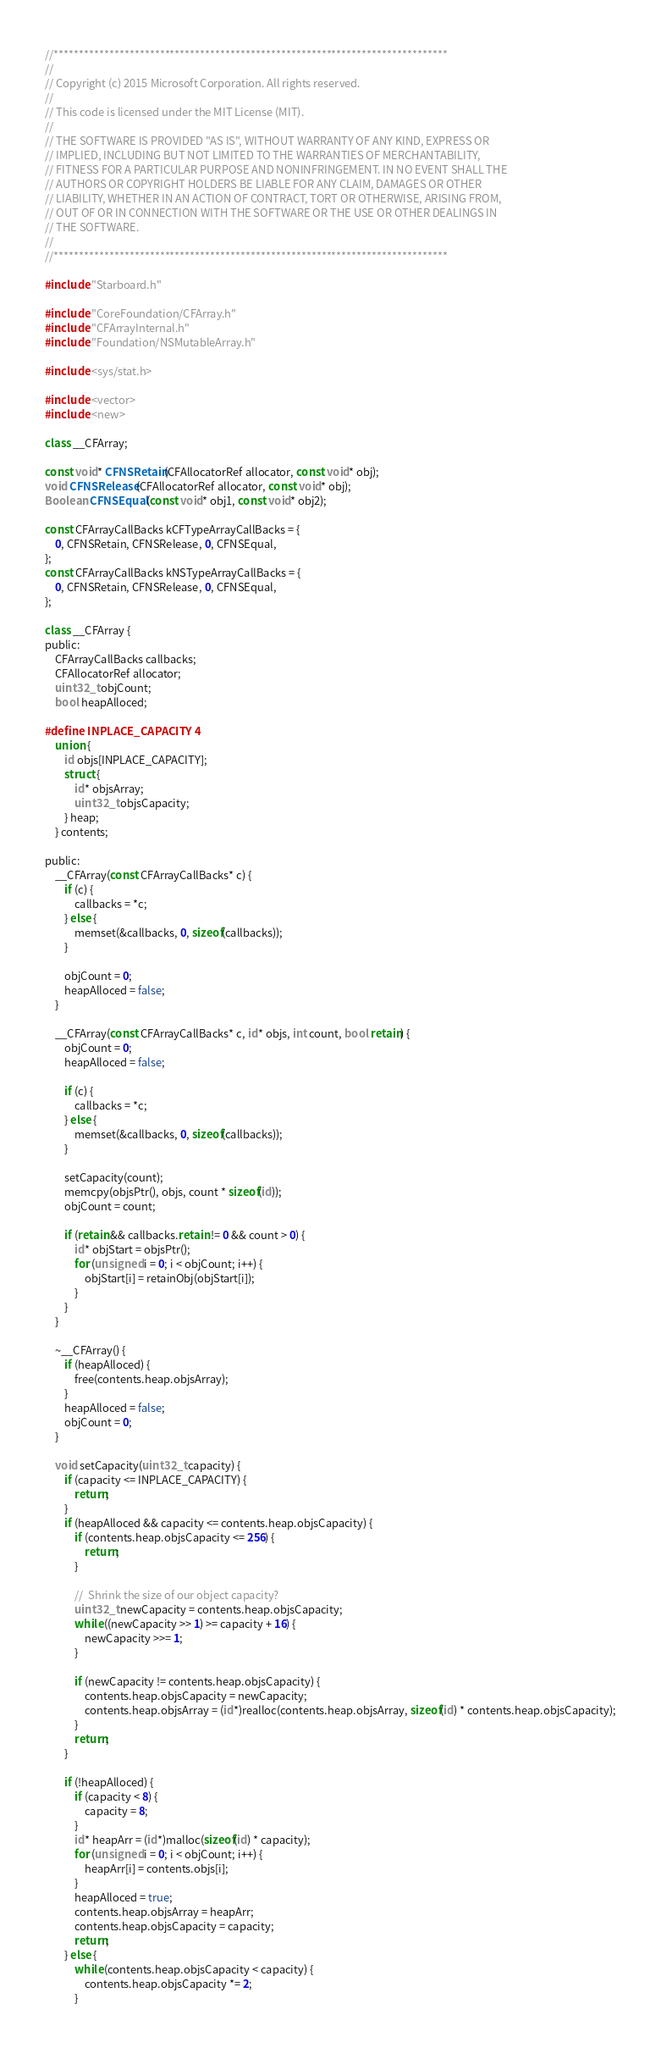Convert code to text. <code><loc_0><loc_0><loc_500><loc_500><_ObjectiveC_>//******************************************************************************
//
// Copyright (c) 2015 Microsoft Corporation. All rights reserved.
//
// This code is licensed under the MIT License (MIT).
//
// THE SOFTWARE IS PROVIDED "AS IS", WITHOUT WARRANTY OF ANY KIND, EXPRESS OR
// IMPLIED, INCLUDING BUT NOT LIMITED TO THE WARRANTIES OF MERCHANTABILITY,
// FITNESS FOR A PARTICULAR PURPOSE AND NONINFRINGEMENT. IN NO EVENT SHALL THE
// AUTHORS OR COPYRIGHT HOLDERS BE LIABLE FOR ANY CLAIM, DAMAGES OR OTHER
// LIABILITY, WHETHER IN AN ACTION OF CONTRACT, TORT OR OTHERWISE, ARISING FROM,
// OUT OF OR IN CONNECTION WITH THE SOFTWARE OR THE USE OR OTHER DEALINGS IN
// THE SOFTWARE.
//
//******************************************************************************

#include "Starboard.h"

#include "CoreFoundation/CFArray.h"
#include "CFArrayInternal.h"
#include "Foundation/NSMutableArray.h"

#include <sys/stat.h>

#include <vector>
#include <new>

class __CFArray;

const void* CFNSRetain(CFAllocatorRef allocator, const void* obj);
void CFNSRelease(CFAllocatorRef allocator, const void* obj);
Boolean CFNSEqual(const void* obj1, const void* obj2);

const CFArrayCallBacks kCFTypeArrayCallBacks = {
    0, CFNSRetain, CFNSRelease, 0, CFNSEqual,
};
const CFArrayCallBacks kNSTypeArrayCallBacks = {
    0, CFNSRetain, CFNSRelease, 0, CFNSEqual,
};

class __CFArray {
public:
    CFArrayCallBacks callbacks;
    CFAllocatorRef allocator;
    uint32_t objCount;
    bool heapAlloced;

#define INPLACE_CAPACITY 4
    union {
        id objs[INPLACE_CAPACITY];
        struct {
            id* objsArray;
            uint32_t objsCapacity;
        } heap;
    } contents;

public:
    __CFArray(const CFArrayCallBacks* c) {
        if (c) {
            callbacks = *c;
        } else {
            memset(&callbacks, 0, sizeof(callbacks));
        }

        objCount = 0;
        heapAlloced = false;
    }

    __CFArray(const CFArrayCallBacks* c, id* objs, int count, bool retain) {
        objCount = 0;
        heapAlloced = false;

        if (c) {
            callbacks = *c;
        } else {
            memset(&callbacks, 0, sizeof(callbacks));
        }

        setCapacity(count);
        memcpy(objsPtr(), objs, count * sizeof(id));
        objCount = count;

        if (retain && callbacks.retain != 0 && count > 0) {
            id* objStart = objsPtr();
            for (unsigned i = 0; i < objCount; i++) {
                objStart[i] = retainObj(objStart[i]);
            }
        }
    }

    ~__CFArray() {
        if (heapAlloced) {
            free(contents.heap.objsArray);
        }
        heapAlloced = false;
        objCount = 0;
    }

    void setCapacity(uint32_t capacity) {
        if (capacity <= INPLACE_CAPACITY) {
            return;
        }
        if (heapAlloced && capacity <= contents.heap.objsCapacity) {
            if (contents.heap.objsCapacity <= 256) {
                return;
            }

            //  Shrink the size of our object capacity?
            uint32_t newCapacity = contents.heap.objsCapacity;
            while ((newCapacity >> 1) >= capacity + 16) {
                newCapacity >>= 1;
            }

            if (newCapacity != contents.heap.objsCapacity) {
                contents.heap.objsCapacity = newCapacity;
                contents.heap.objsArray = (id*)realloc(contents.heap.objsArray, sizeof(id) * contents.heap.objsCapacity);
            }
            return;
        }

        if (!heapAlloced) {
            if (capacity < 8) {
                capacity = 8;
            }
            id* heapArr = (id*)malloc(sizeof(id) * capacity);
            for (unsigned i = 0; i < objCount; i++) {
                heapArr[i] = contents.objs[i];
            }
            heapAlloced = true;
            contents.heap.objsArray = heapArr;
            contents.heap.objsCapacity = capacity;
            return;
        } else {
            while (contents.heap.objsCapacity < capacity) {
                contents.heap.objsCapacity *= 2;
            }</code> 